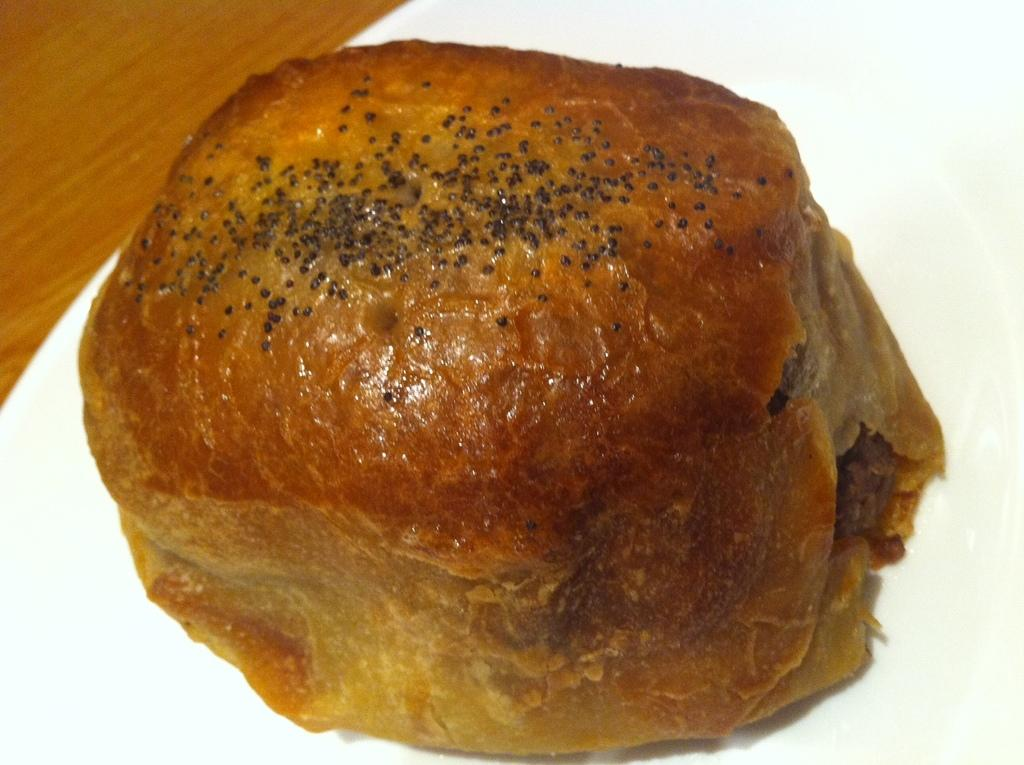What piece of furniture is present in the image? There is a table in the image. What is placed on the table? There is a fruit on the table. What part of the room can be seen on the left side of the image? The floor is visible on the left side of the image. What type of amusement can be seen on the table in the image? There is no amusement present on the table in the image; it features a fruit. What is the yoke used for in the image? There is no yoke present in the image. 